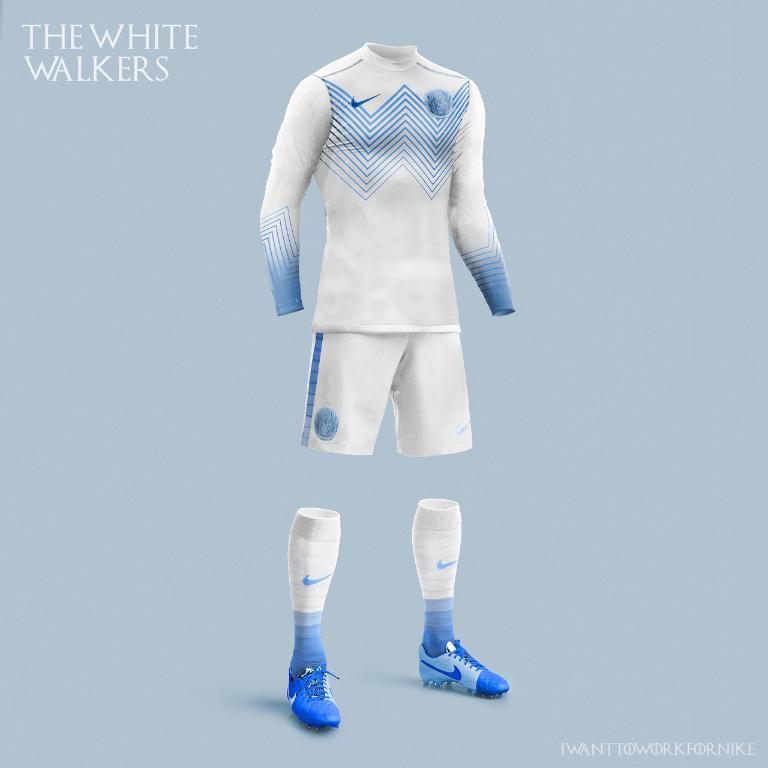Could you give a brief overview of what you see in this image? In this image I can see the clothes, socks and shoes. 